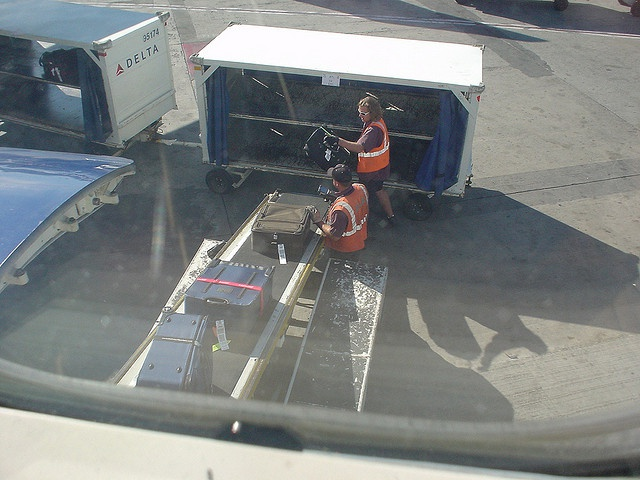Describe the objects in this image and their specific colors. I can see suitcase in darkgray and gray tones, suitcase in darkgray and gray tones, people in darkgray, gray, brown, black, and maroon tones, people in darkgray, gray, black, brown, and purple tones, and suitcase in darkgray and gray tones in this image. 